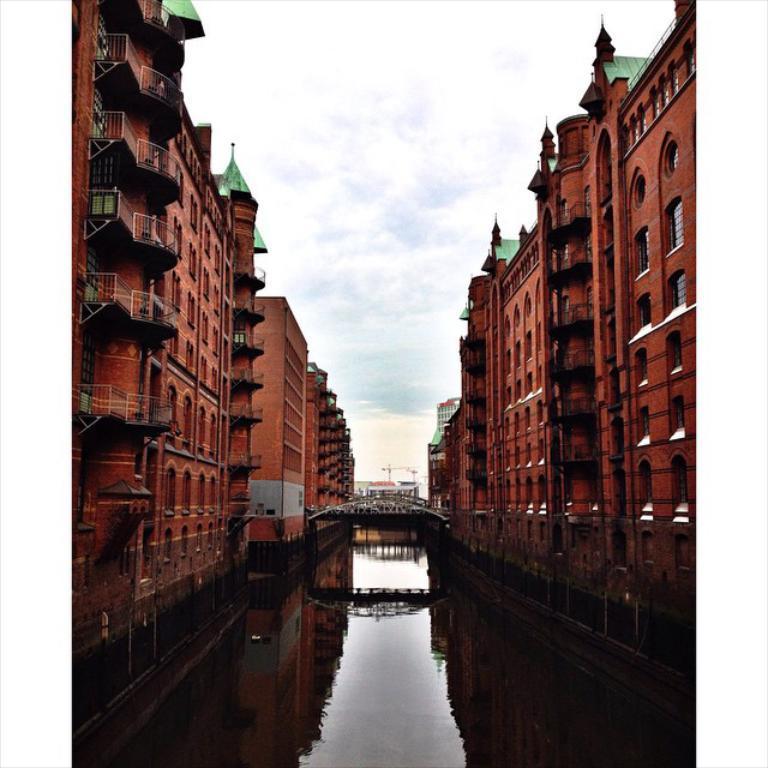Please provide a concise description of this image. In the center of the image there is a bridge. There is water. To both sides of the image there are buildings. At the top of the image there is sky and clouds. 